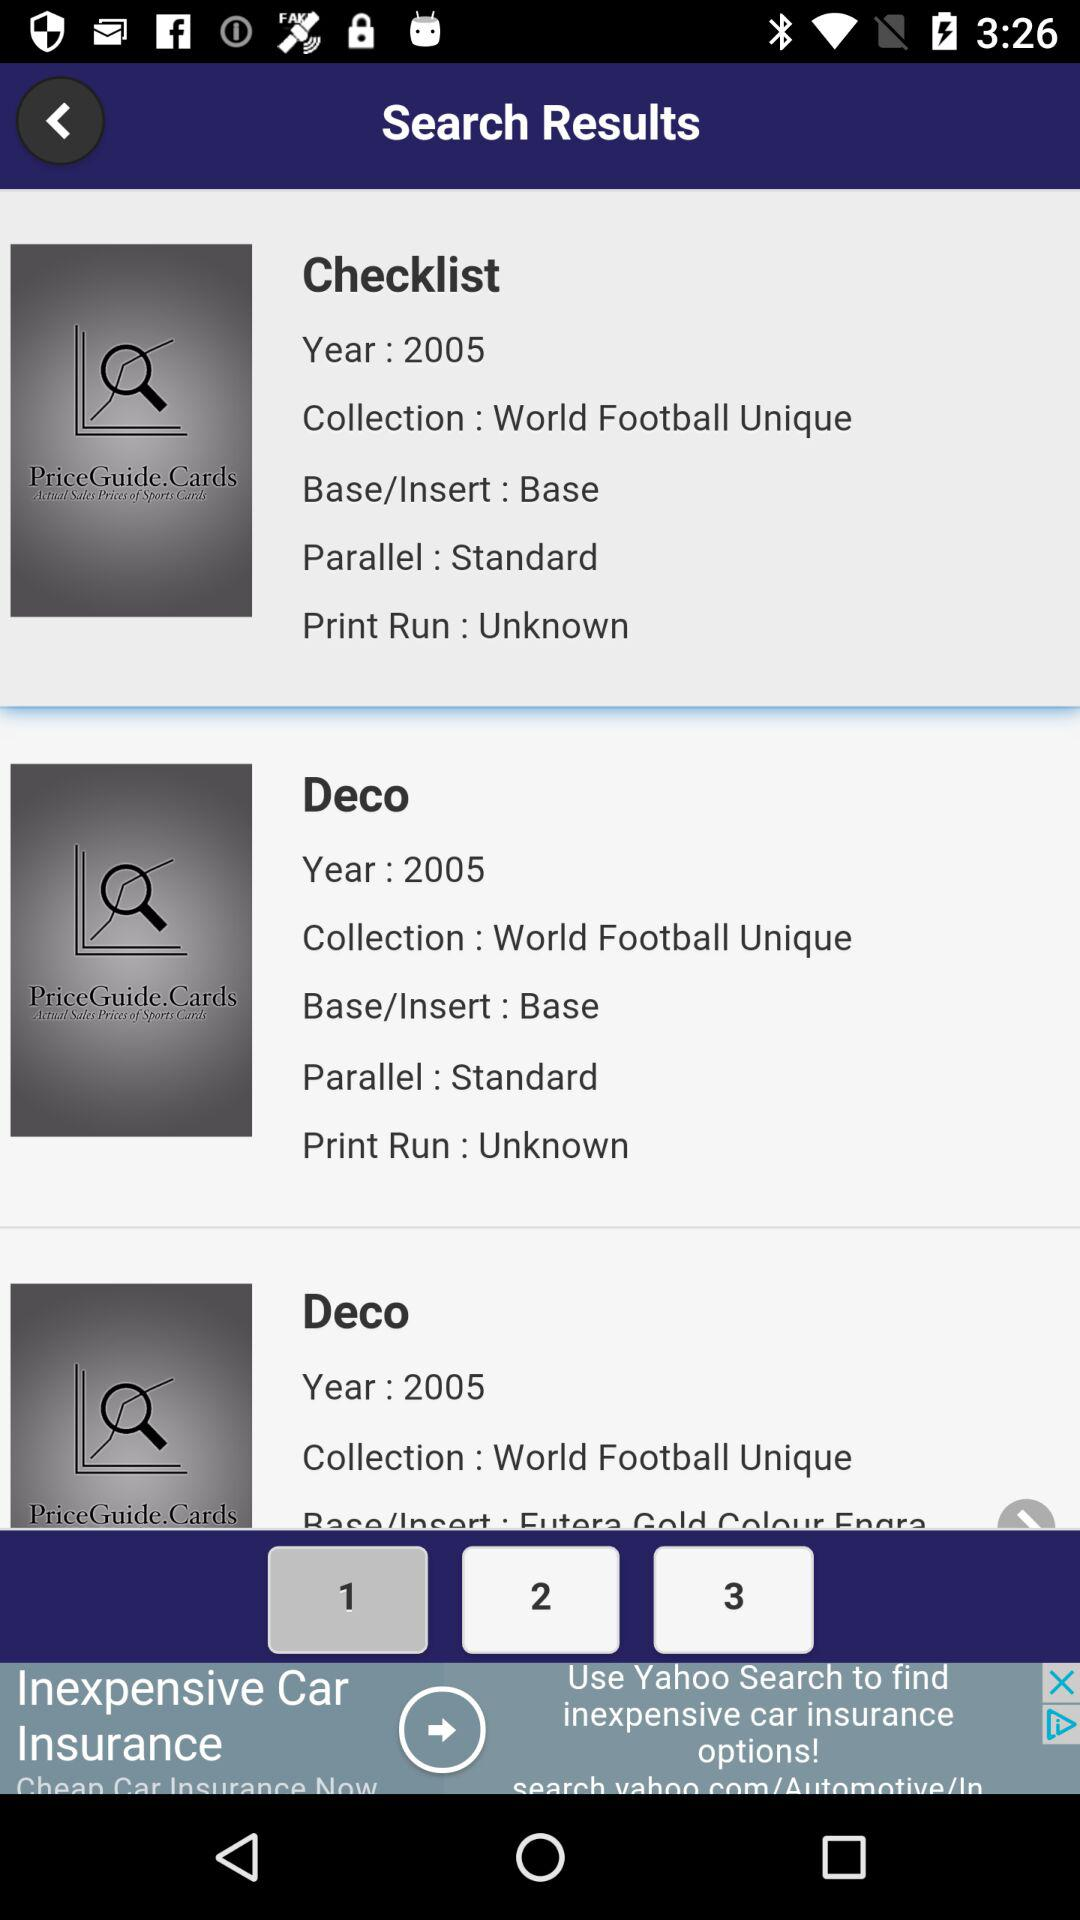What is the year of "Deco"? The year is 2005. 